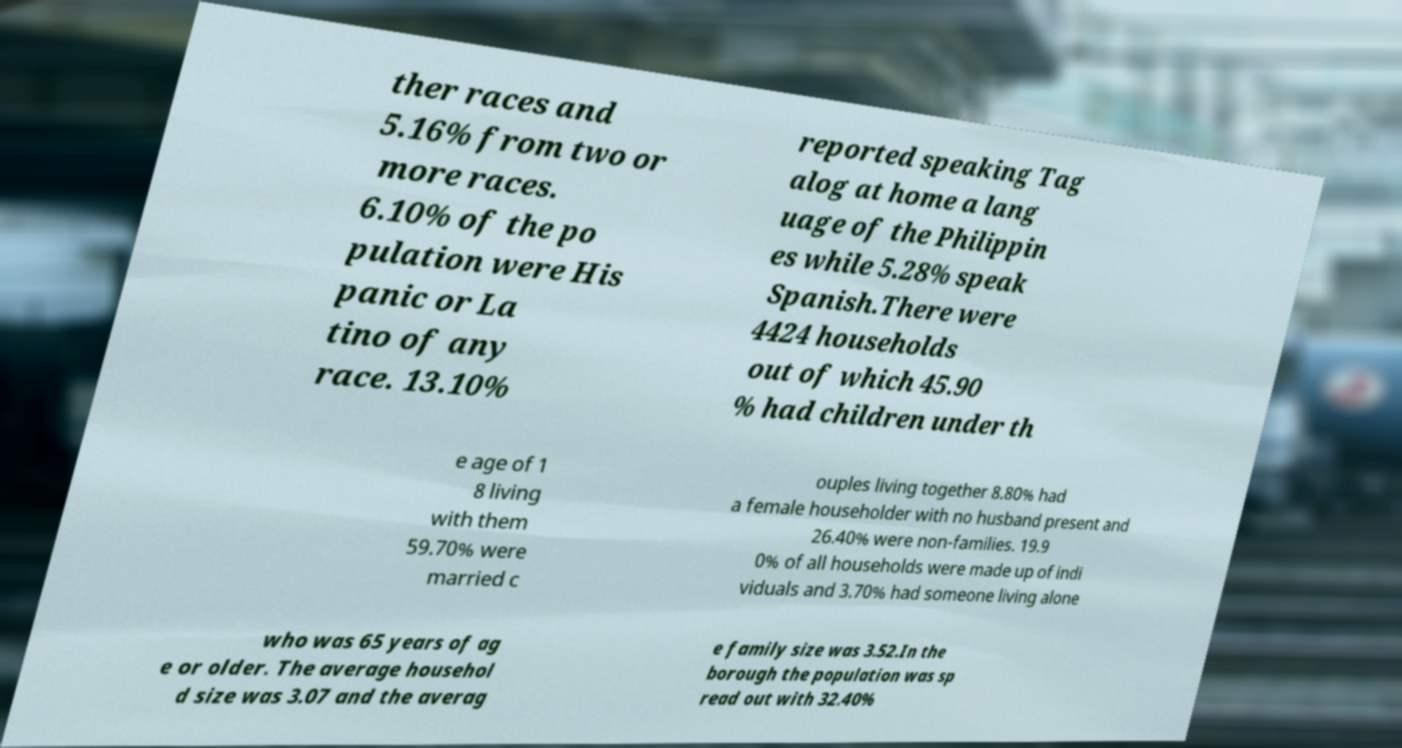Could you extract and type out the text from this image? ther races and 5.16% from two or more races. 6.10% of the po pulation were His panic or La tino of any race. 13.10% reported speaking Tag alog at home a lang uage of the Philippin es while 5.28% speak Spanish.There were 4424 households out of which 45.90 % had children under th e age of 1 8 living with them 59.70% were married c ouples living together 8.80% had a female householder with no husband present and 26.40% were non-families. 19.9 0% of all households were made up of indi viduals and 3.70% had someone living alone who was 65 years of ag e or older. The average househol d size was 3.07 and the averag e family size was 3.52.In the borough the population was sp read out with 32.40% 